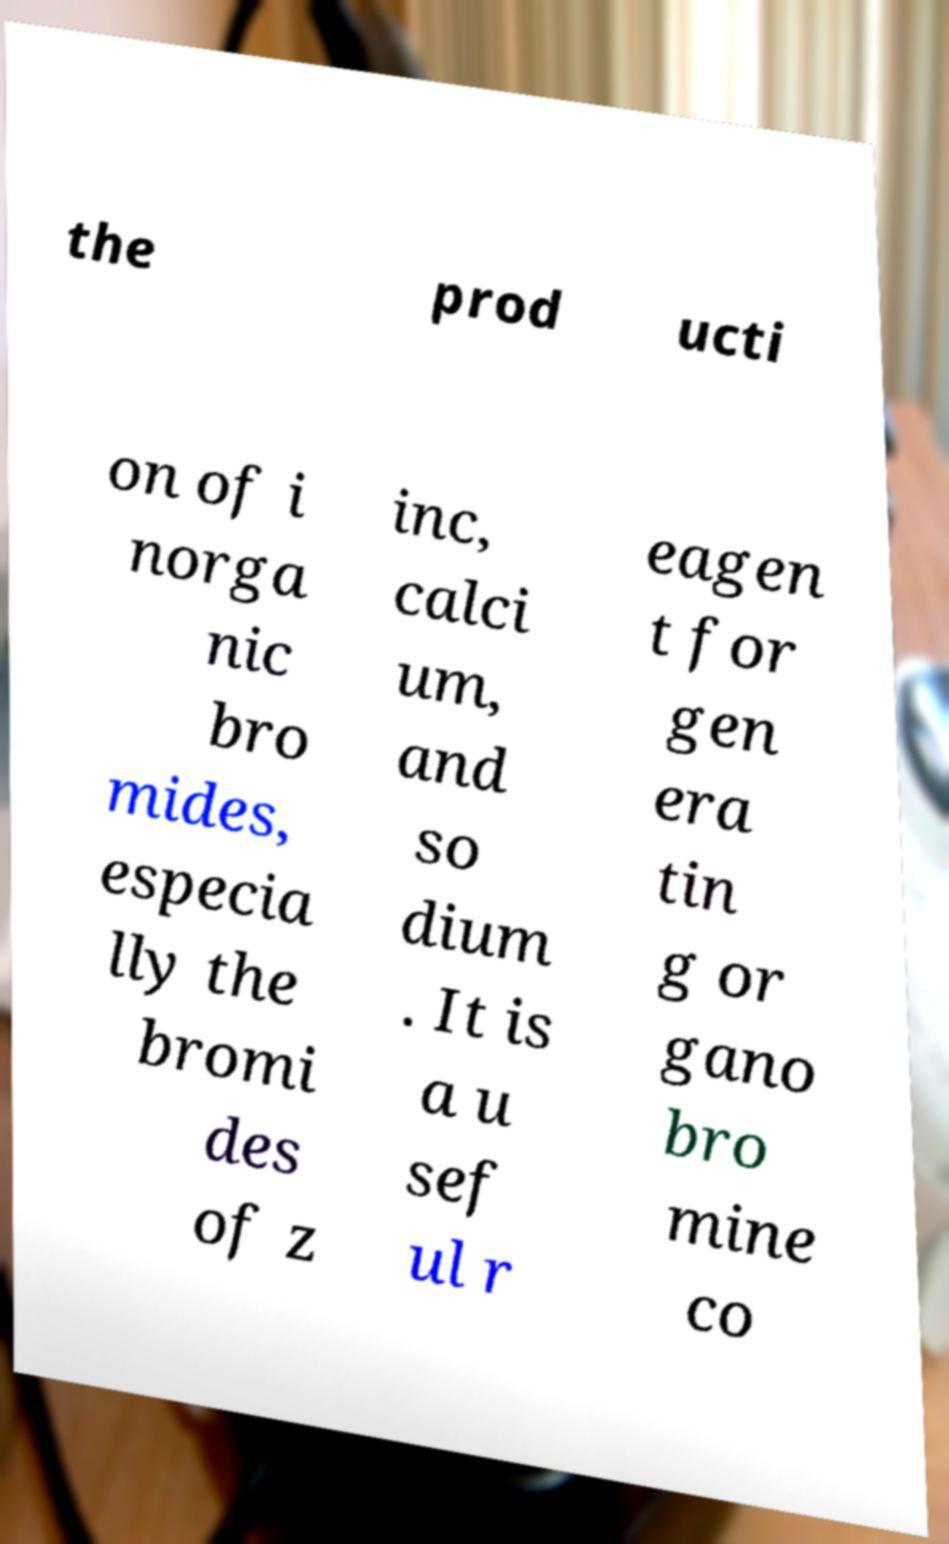Could you extract and type out the text from this image? the prod ucti on of i norga nic bro mides, especia lly the bromi des of z inc, calci um, and so dium . It is a u sef ul r eagen t for gen era tin g or gano bro mine co 